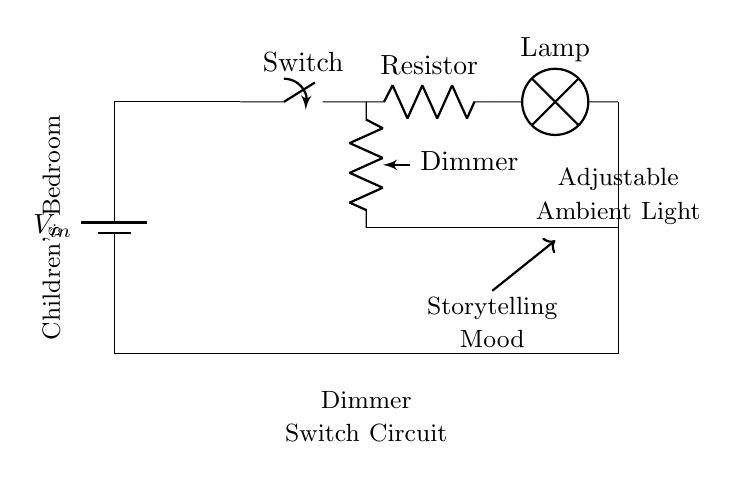What is the primary function of this circuit? The primary function of this circuit is to adjust ambient lighting, specifically to create a suitable lighting level for storytelling sessions in a child's bedroom. This can be achieved through the dimmer switch, which allows the user to control the brightness of the lamp.
Answer: Adjust ambient lighting What type of switch is used in this circuit? The circuit uses a Single Pole Single Throw (SPST) switch, which can either connect or disconnect the lamp from the circuit but serves a single function of turning the light on or off.
Answer: SPST switch What component is responsible for changing the brightness of the lamp? The dimmer switch, denoted as a pR in the circuit, is responsible for changing the brightness of the lamp by varying the resistance in the circuit.
Answer: Dimmer switch How many lamps can this circuit support? The circuit as drawn supports one lamp, as there is a single lamp component connected to the circuit.
Answer: One lamp What materials can be used for the resistive element in the dimmer switch? The resistive element in a dimmer switch can be made from materials like carbon, wire-wound, or ceramics, which can handle variable loads and provide adjustable resistance to control brightness.
Answer: Various materials (carbon, wire-wound, ceramics) In which room is this circuit designed to be used? The circuit is specifically designed for use in a children's bedroom, as indicated by the labeling in the circuit diagram. This suggests it is tailored for creating a cozy atmosphere during bedtime storytelling.
Answer: Children's bedroom What does the text "Storytelling Mood" imply about this circuit? The text "Storytelling Mood" implies that the circuit is designed to create an atmosphere conducive to storytelling, likely through the adjustment of light levels to foster a calming or inviting environment.
Answer: Storytelling atmosphere 